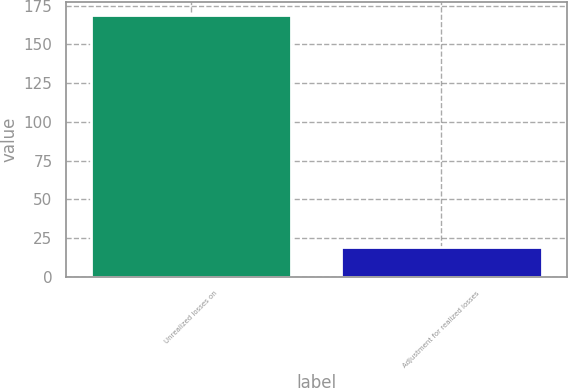Convert chart to OTSL. <chart><loc_0><loc_0><loc_500><loc_500><bar_chart><fcel>Unrealized losses on<fcel>Adjustment for realized losses<nl><fcel>168.9<fcel>19<nl></chart> 